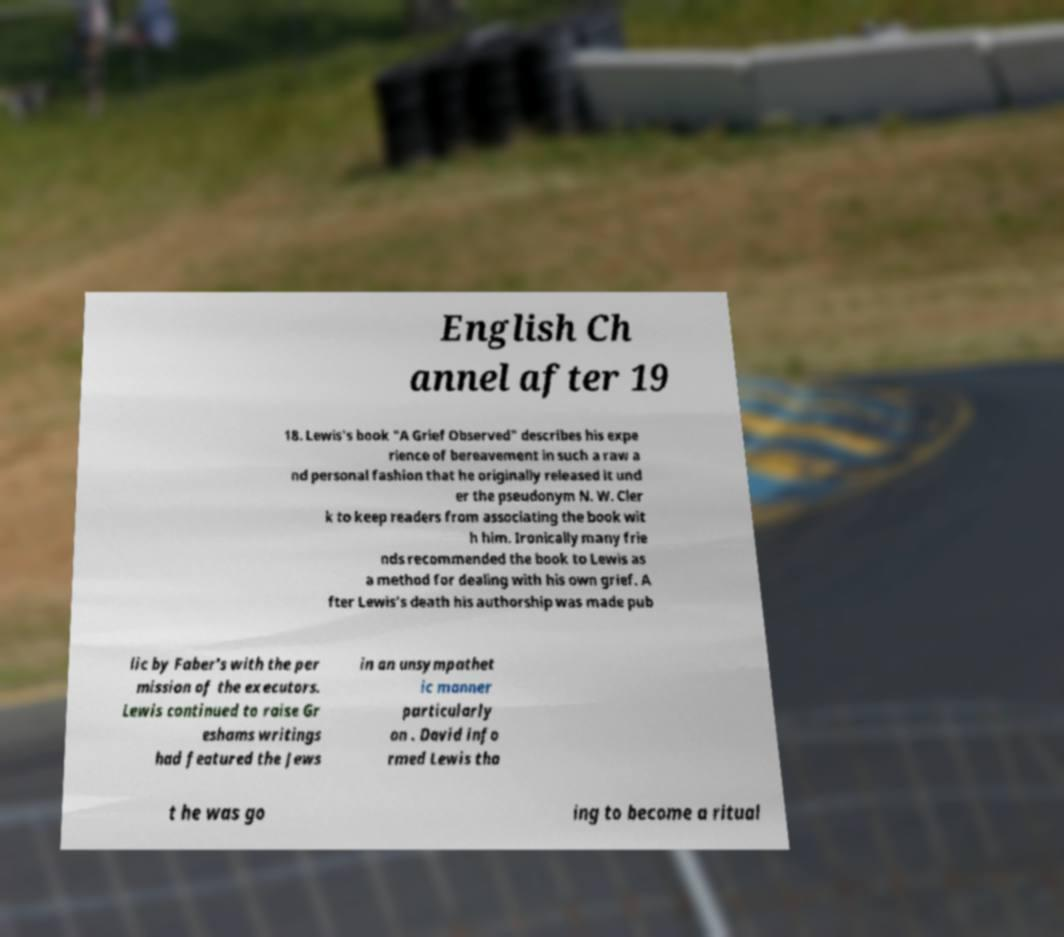Can you accurately transcribe the text from the provided image for me? English Ch annel after 19 18. Lewis's book "A Grief Observed" describes his expe rience of bereavement in such a raw a nd personal fashion that he originally released it und er the pseudonym N. W. Cler k to keep readers from associating the book wit h him. Ironically many frie nds recommended the book to Lewis as a method for dealing with his own grief. A fter Lewis's death his authorship was made pub lic by Faber's with the per mission of the executors. Lewis continued to raise Gr eshams writings had featured the Jews in an unsympathet ic manner particularly on . David info rmed Lewis tha t he was go ing to become a ritual 